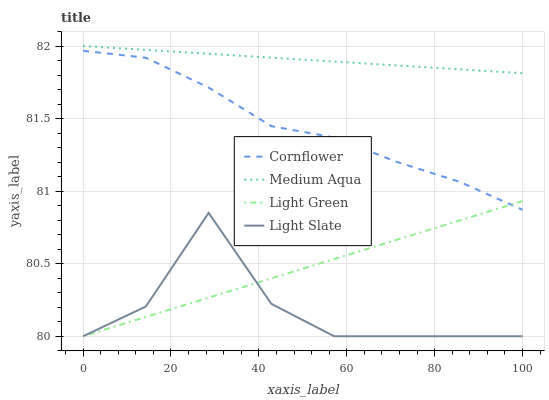Does Light Slate have the minimum area under the curve?
Answer yes or no. Yes. Does Medium Aqua have the maximum area under the curve?
Answer yes or no. Yes. Does Cornflower have the minimum area under the curve?
Answer yes or no. No. Does Cornflower have the maximum area under the curve?
Answer yes or no. No. Is Medium Aqua the smoothest?
Answer yes or no. Yes. Is Light Slate the roughest?
Answer yes or no. Yes. Is Cornflower the smoothest?
Answer yes or no. No. Is Cornflower the roughest?
Answer yes or no. No. Does Light Slate have the lowest value?
Answer yes or no. Yes. Does Cornflower have the lowest value?
Answer yes or no. No. Does Medium Aqua have the highest value?
Answer yes or no. Yes. Does Cornflower have the highest value?
Answer yes or no. No. Is Light Slate less than Cornflower?
Answer yes or no. Yes. Is Medium Aqua greater than Light Green?
Answer yes or no. Yes. Does Light Green intersect Light Slate?
Answer yes or no. Yes. Is Light Green less than Light Slate?
Answer yes or no. No. Is Light Green greater than Light Slate?
Answer yes or no. No. Does Light Slate intersect Cornflower?
Answer yes or no. No. 